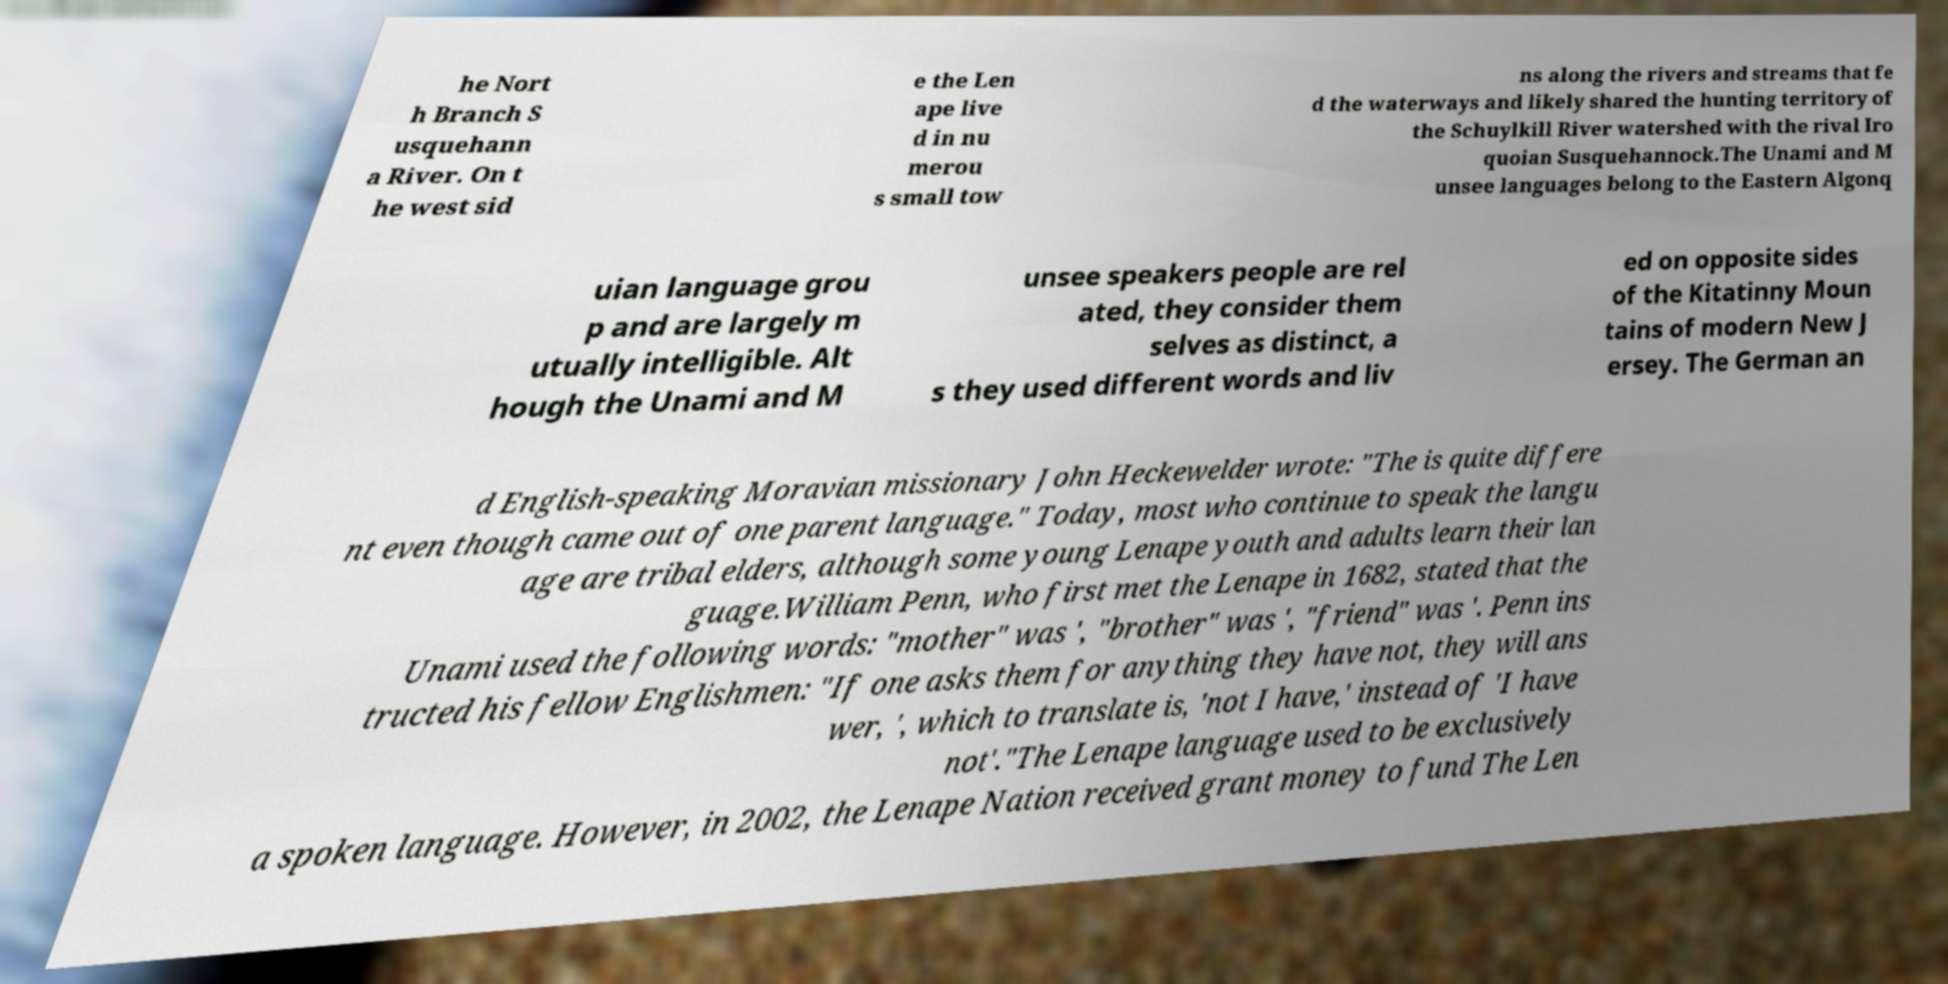I need the written content from this picture converted into text. Can you do that? he Nort h Branch S usquehann a River. On t he west sid e the Len ape live d in nu merou s small tow ns along the rivers and streams that fe d the waterways and likely shared the hunting territory of the Schuylkill River watershed with the rival Iro quoian Susquehannock.The Unami and M unsee languages belong to the Eastern Algonq uian language grou p and are largely m utually intelligible. Alt hough the Unami and M unsee speakers people are rel ated, they consider them selves as distinct, a s they used different words and liv ed on opposite sides of the Kitatinny Moun tains of modern New J ersey. The German an d English-speaking Moravian missionary John Heckewelder wrote: "The is quite differe nt even though came out of one parent language." Today, most who continue to speak the langu age are tribal elders, although some young Lenape youth and adults learn their lan guage.William Penn, who first met the Lenape in 1682, stated that the Unami used the following words: "mother" was ', "brother" was ', "friend" was '. Penn ins tructed his fellow Englishmen: "If one asks them for anything they have not, they will ans wer, ', which to translate is, 'not I have,' instead of 'I have not'."The Lenape language used to be exclusively a spoken language. However, in 2002, the Lenape Nation received grant money to fund The Len 